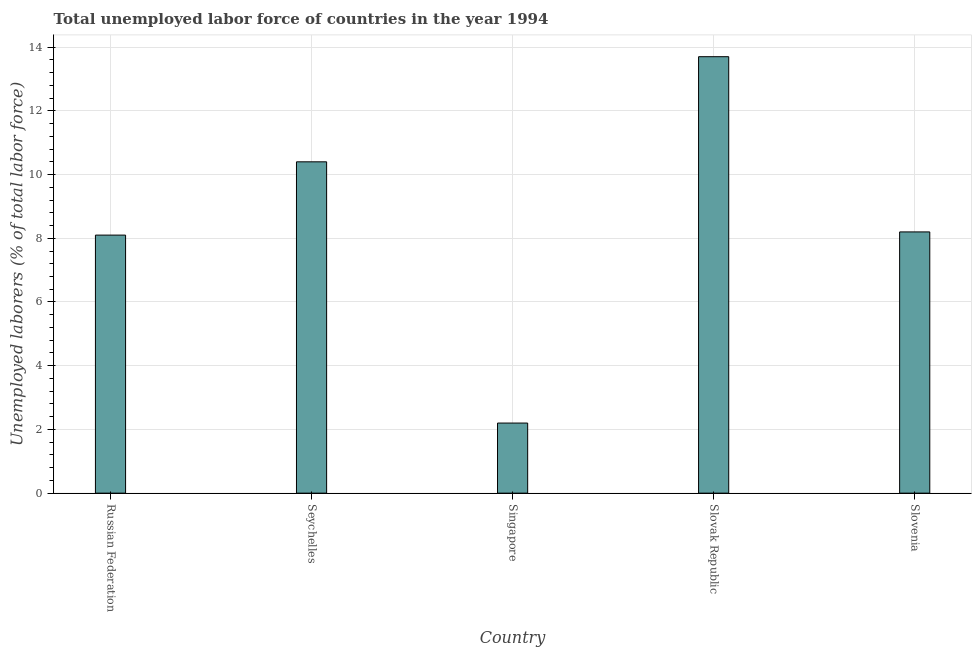Does the graph contain grids?
Give a very brief answer. Yes. What is the title of the graph?
Offer a terse response. Total unemployed labor force of countries in the year 1994. What is the label or title of the Y-axis?
Give a very brief answer. Unemployed laborers (% of total labor force). What is the total unemployed labour force in Slovenia?
Offer a very short reply. 8.2. Across all countries, what is the maximum total unemployed labour force?
Offer a very short reply. 13.7. Across all countries, what is the minimum total unemployed labour force?
Your answer should be compact. 2.2. In which country was the total unemployed labour force maximum?
Your answer should be compact. Slovak Republic. In which country was the total unemployed labour force minimum?
Offer a terse response. Singapore. What is the sum of the total unemployed labour force?
Provide a succinct answer. 42.6. What is the average total unemployed labour force per country?
Keep it short and to the point. 8.52. What is the median total unemployed labour force?
Ensure brevity in your answer.  8.2. What is the ratio of the total unemployed labour force in Russian Federation to that in Slovak Republic?
Your answer should be compact. 0.59. Is the total unemployed labour force in Russian Federation less than that in Singapore?
Provide a short and direct response. No. What is the difference between the highest and the second highest total unemployed labour force?
Your answer should be very brief. 3.3. What is the difference between the highest and the lowest total unemployed labour force?
Make the answer very short. 11.5. In how many countries, is the total unemployed labour force greater than the average total unemployed labour force taken over all countries?
Give a very brief answer. 2. How many bars are there?
Keep it short and to the point. 5. What is the difference between two consecutive major ticks on the Y-axis?
Offer a very short reply. 2. Are the values on the major ticks of Y-axis written in scientific E-notation?
Provide a succinct answer. No. What is the Unemployed laborers (% of total labor force) of Russian Federation?
Your response must be concise. 8.1. What is the Unemployed laborers (% of total labor force) in Seychelles?
Offer a very short reply. 10.4. What is the Unemployed laborers (% of total labor force) in Singapore?
Provide a short and direct response. 2.2. What is the Unemployed laborers (% of total labor force) in Slovak Republic?
Keep it short and to the point. 13.7. What is the Unemployed laborers (% of total labor force) in Slovenia?
Your answer should be very brief. 8.2. What is the difference between the Unemployed laborers (% of total labor force) in Russian Federation and Slovenia?
Your response must be concise. -0.1. What is the difference between the Unemployed laborers (% of total labor force) in Seychelles and Slovak Republic?
Provide a succinct answer. -3.3. What is the difference between the Unemployed laborers (% of total labor force) in Singapore and Slovak Republic?
Ensure brevity in your answer.  -11.5. What is the ratio of the Unemployed laborers (% of total labor force) in Russian Federation to that in Seychelles?
Your answer should be very brief. 0.78. What is the ratio of the Unemployed laborers (% of total labor force) in Russian Federation to that in Singapore?
Make the answer very short. 3.68. What is the ratio of the Unemployed laborers (% of total labor force) in Russian Federation to that in Slovak Republic?
Your answer should be very brief. 0.59. What is the ratio of the Unemployed laborers (% of total labor force) in Seychelles to that in Singapore?
Provide a short and direct response. 4.73. What is the ratio of the Unemployed laborers (% of total labor force) in Seychelles to that in Slovak Republic?
Keep it short and to the point. 0.76. What is the ratio of the Unemployed laborers (% of total labor force) in Seychelles to that in Slovenia?
Your answer should be very brief. 1.27. What is the ratio of the Unemployed laborers (% of total labor force) in Singapore to that in Slovak Republic?
Your response must be concise. 0.16. What is the ratio of the Unemployed laborers (% of total labor force) in Singapore to that in Slovenia?
Make the answer very short. 0.27. What is the ratio of the Unemployed laborers (% of total labor force) in Slovak Republic to that in Slovenia?
Give a very brief answer. 1.67. 